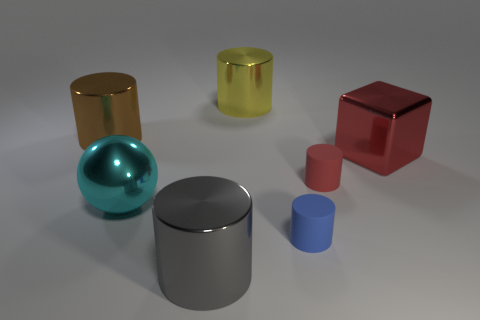Subtract all yellow cylinders. How many cylinders are left? 4 Subtract all tiny blue cylinders. How many cylinders are left? 4 Subtract all cyan cylinders. Subtract all purple balls. How many cylinders are left? 5 Add 3 big blue blocks. How many objects exist? 10 Subtract all cylinders. How many objects are left? 2 Subtract all red things. Subtract all red cylinders. How many objects are left? 4 Add 4 large spheres. How many large spheres are left? 5 Add 1 big brown balls. How many big brown balls exist? 1 Subtract 0 green cubes. How many objects are left? 7 